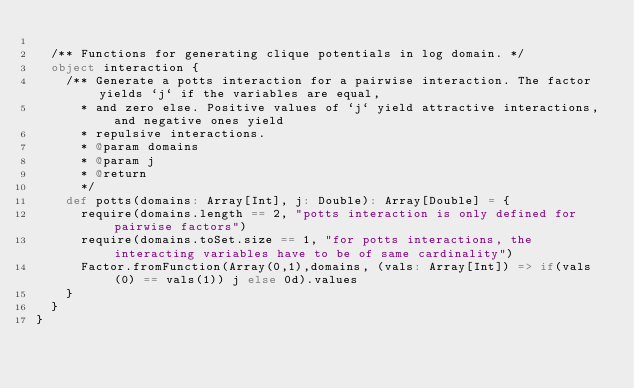<code> <loc_0><loc_0><loc_500><loc_500><_Scala_>
  /** Functions for generating clique potentials in log domain. */
  object interaction {
    /** Generate a potts interaction for a pairwise interaction. The factor yields `j` if the variables are equal,
      * and zero else. Positive values of `j` yield attractive interactions, and negative ones yield
      * repulsive interactions.
      * @param domains
      * @param j
      * @return
      */
    def potts(domains: Array[Int], j: Double): Array[Double] = {
      require(domains.length == 2, "potts interaction is only defined for pairwise factors")
      require(domains.toSet.size == 1, "for potts interactions, the interacting variables have to be of same cardinality")
      Factor.fromFunction(Array(0,1),domains, (vals: Array[Int]) => if(vals(0) == vals(1)) j else 0d).values
    }
  }
}
</code> 